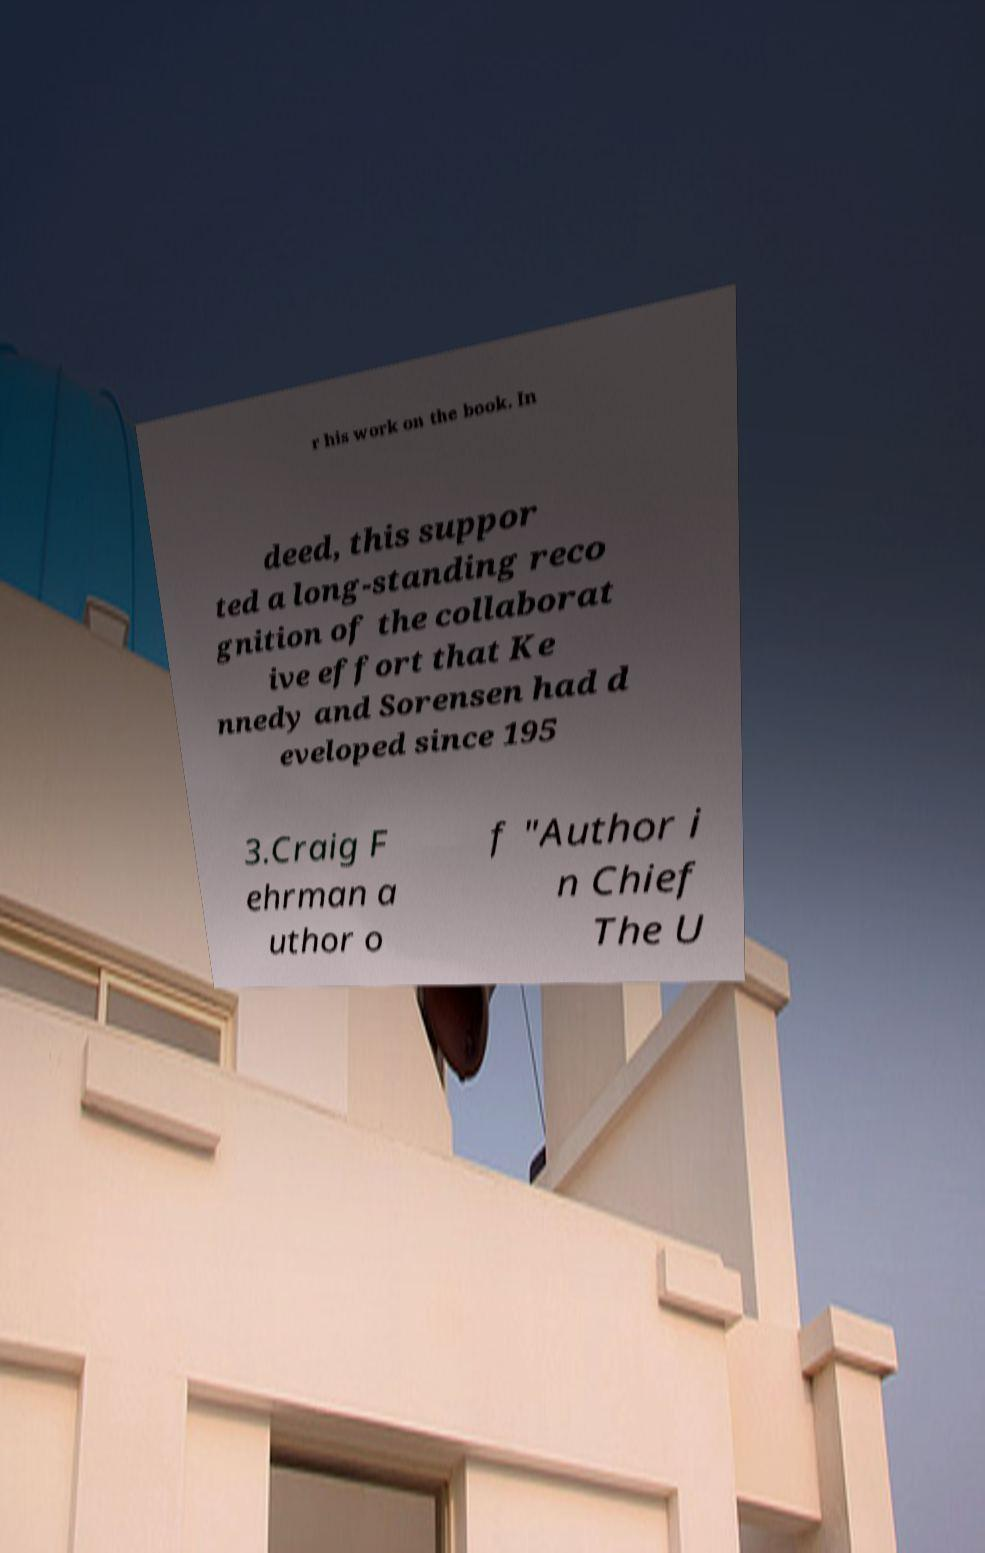What messages or text are displayed in this image? I need them in a readable, typed format. r his work on the book. In deed, this suppor ted a long-standing reco gnition of the collaborat ive effort that Ke nnedy and Sorensen had d eveloped since 195 3.Craig F ehrman a uthor o f "Author i n Chief The U 